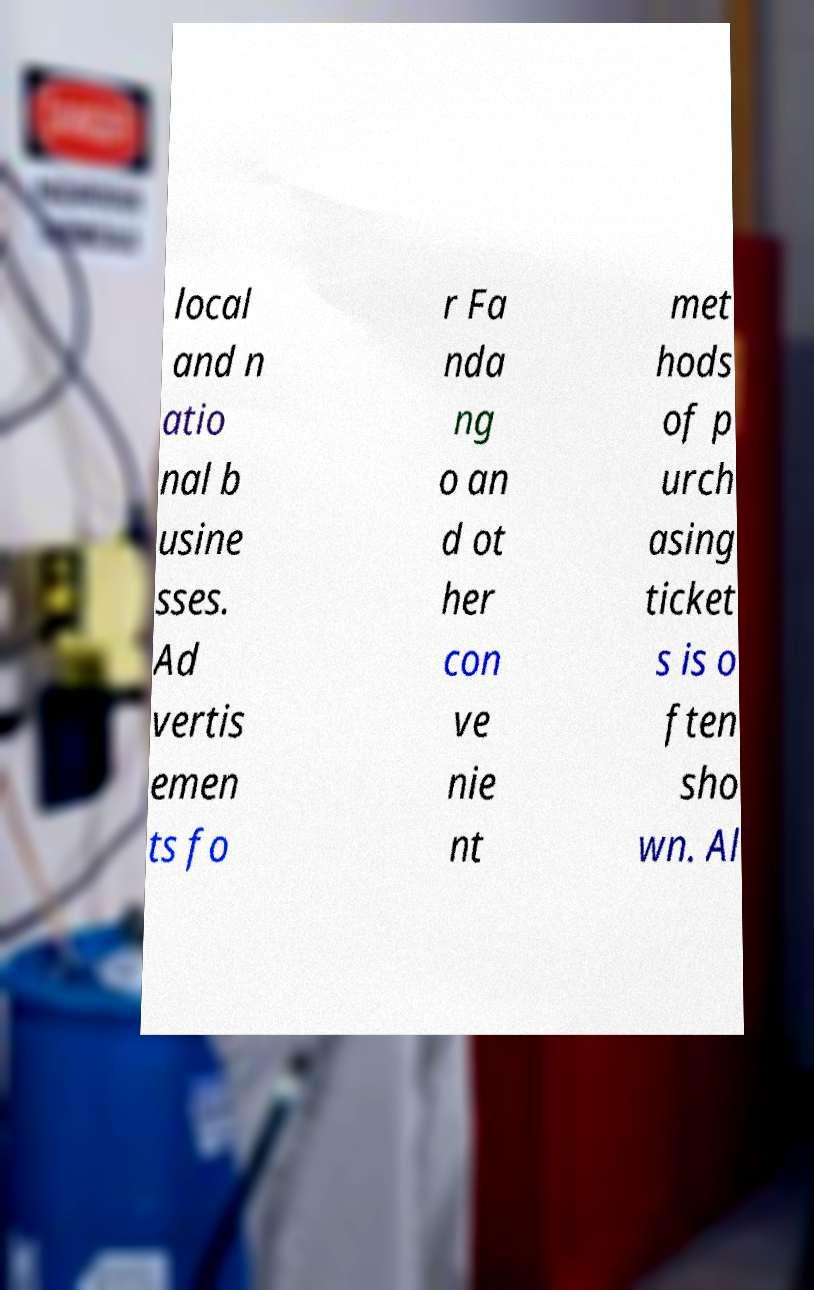Can you accurately transcribe the text from the provided image for me? local and n atio nal b usine sses. Ad vertis emen ts fo r Fa nda ng o an d ot her con ve nie nt met hods of p urch asing ticket s is o ften sho wn. Al 